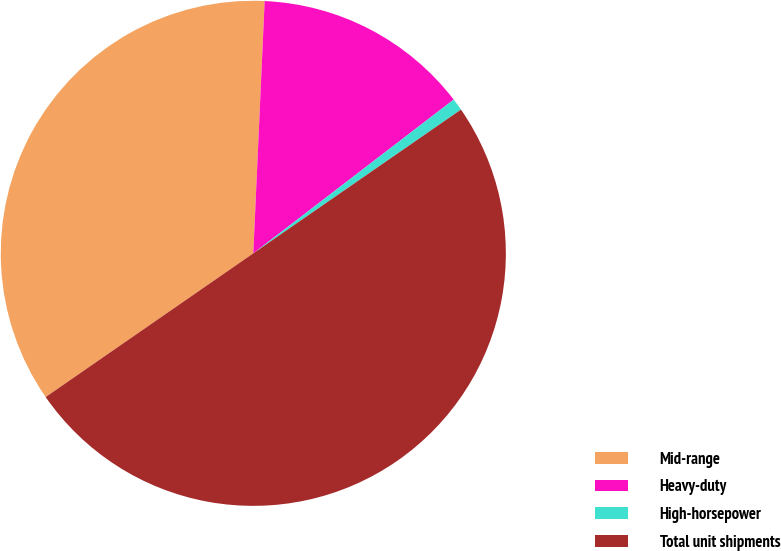Convert chart to OTSL. <chart><loc_0><loc_0><loc_500><loc_500><pie_chart><fcel>Mid-range<fcel>Heavy-duty<fcel>High-horsepower<fcel>Total unit shipments<nl><fcel>35.35%<fcel>13.87%<fcel>0.78%<fcel>50.0%<nl></chart> 